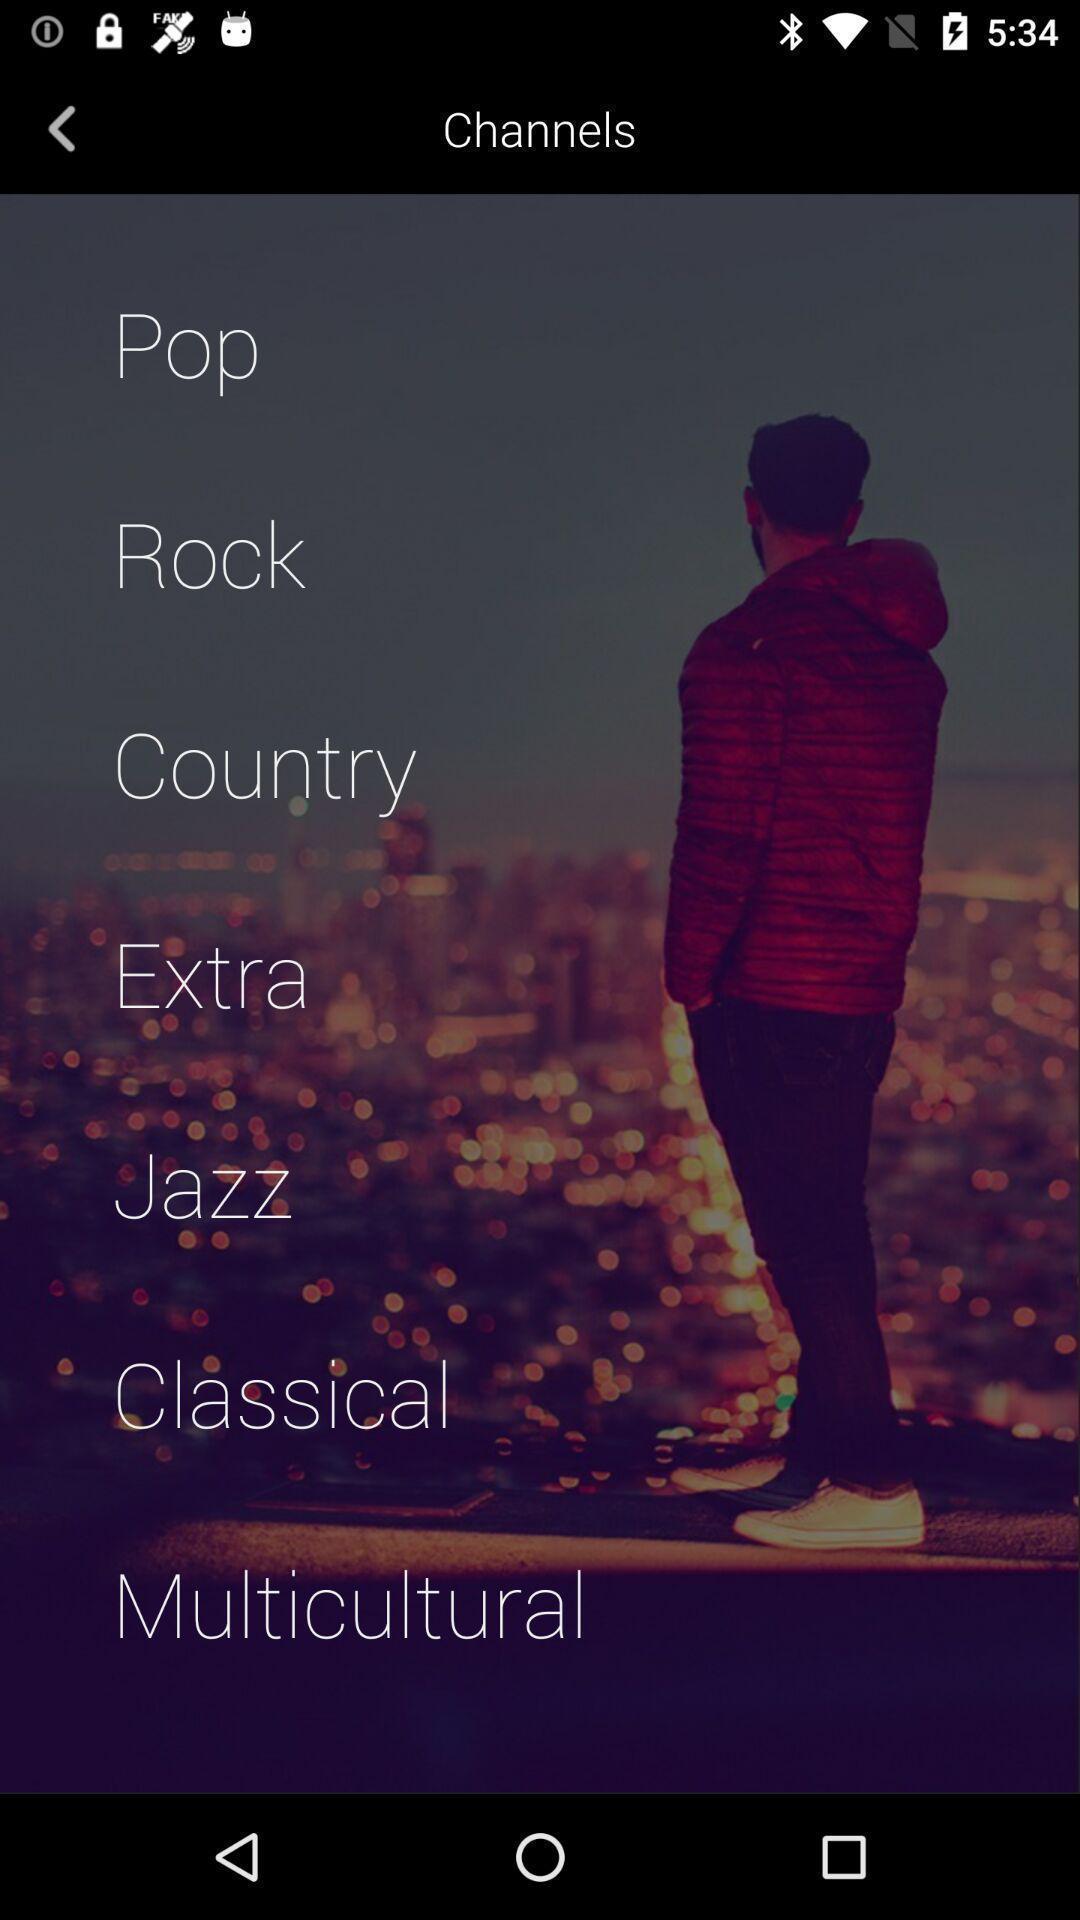Describe this image in words. Page displaying list of channels. 